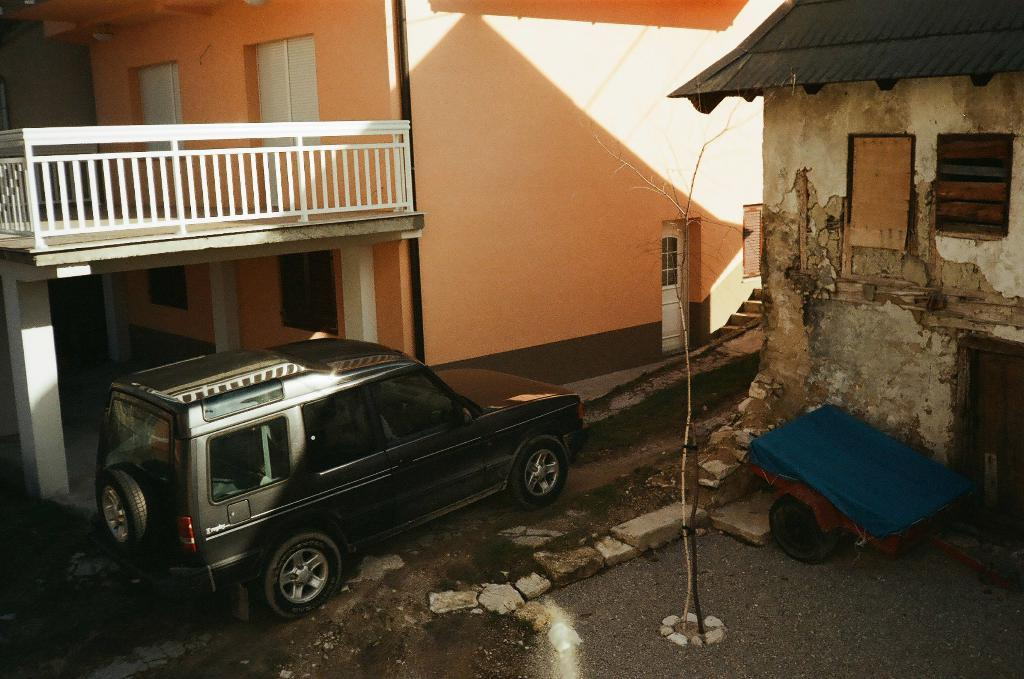What type of vehicle is parked in the image? The fact does not specify the type of vehicle, only that there is a vehicle parked in the image. Can you describe the house in the image? The fact only mentions that there is a house in the image, but no specific details are provided. What is the relationship between the vehicle and the house in the image? The facts do not provide any information about the relationship between the vehicle and the house. What type of honey can be seen dripping from the volcano in the image? There is no mention of honey or a volcano in the image, so this question cannot be answered. 